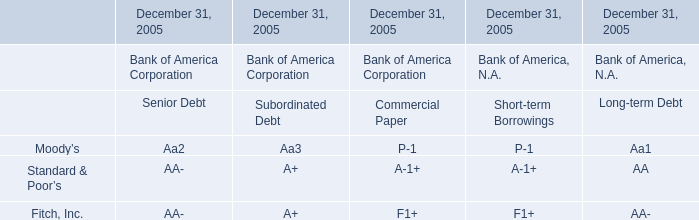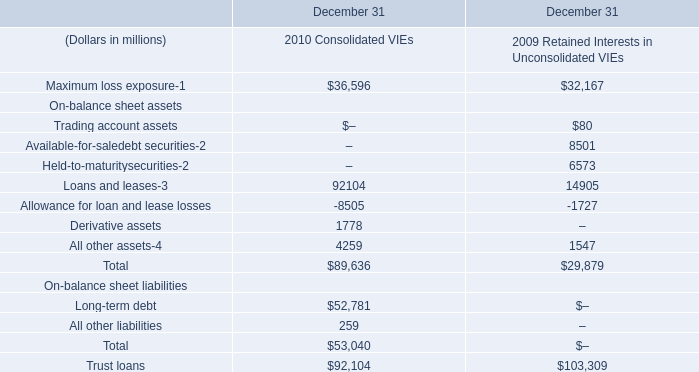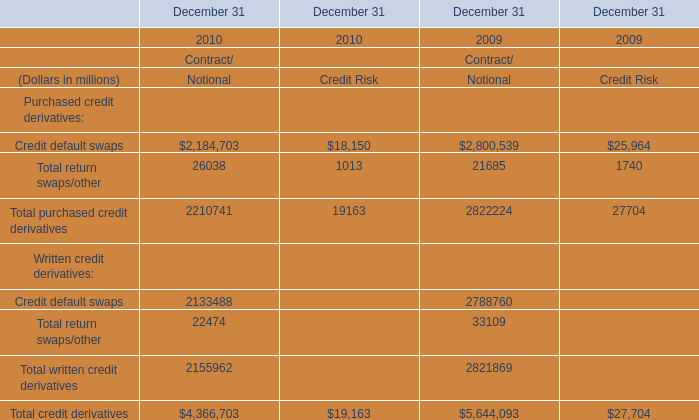What is the total amount of Maximum loss exposure of December 31 2010 Consolidated VIEs, and Credit default swaps of December 31 2009 Credit Risk ? 
Computations: (36596.0 + 25964.0)
Answer: 62560.0. 